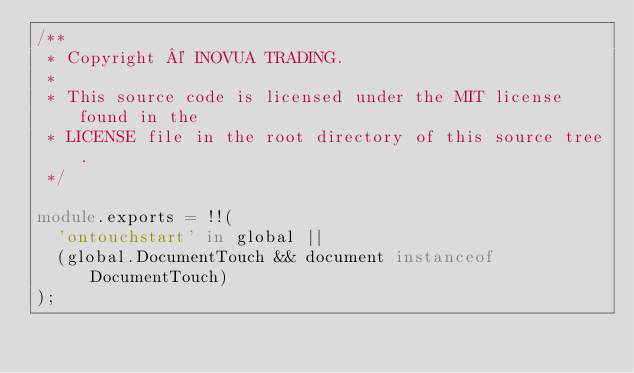<code> <loc_0><loc_0><loc_500><loc_500><_TypeScript_>/**
 * Copyright © INOVUA TRADING.
 *
 * This source code is licensed under the MIT license found in the
 * LICENSE file in the root directory of this source tree.
 */

module.exports = !!(
  'ontouchstart' in global ||
  (global.DocumentTouch && document instanceof DocumentTouch)
);
</code> 